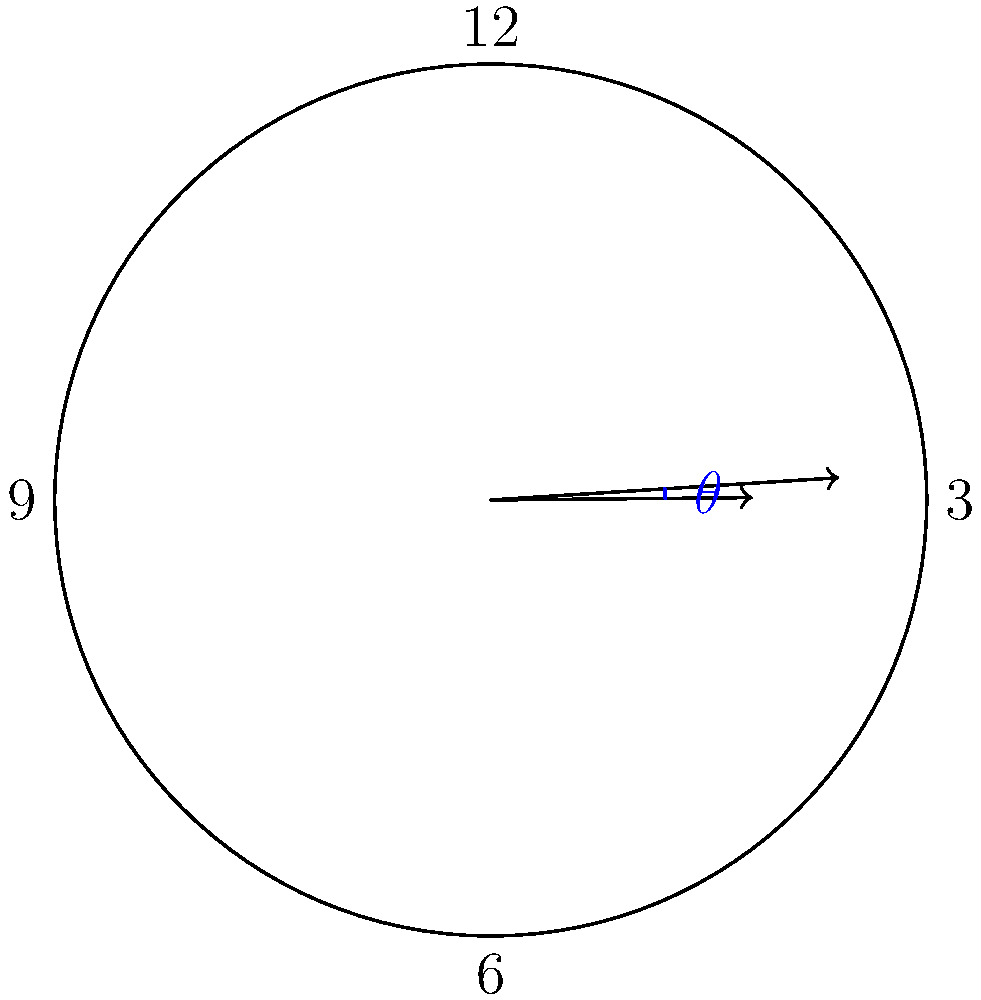Imagine you're playing with a magical clock that can show any time you want! If the hour hand points to 1 and the minute hand points to 7, what is the smallest angle $\theta$ (in degrees) between the two hands? Remember, the clock face is divided into 12 equal parts! Let's solve this step-by-step:

1) First, we need to understand how the clock hands move:
   - The hour hand makes a complete 360° rotation in 12 hours, so it moves at 360° ÷ 12 = 30° per hour.
   - The minute hand makes a complete 360° rotation in 1 hour, so it moves at 360° ÷ 60 = 6° per minute.

2) When the hour hand points to 1, it has moved 30° from the 12 o'clock position.

3) When the minute hand points to 7, it has moved 7 × 30° = 210° from the 12 o'clock position.

4) The angle between the hands is the absolute difference between these angles:
   $|\text{Minute hand angle} - \text{Hour hand angle}| = |210° - 30°| = 180°$

5) However, we need to find the smallest angle. If the angle is greater than 180°, we can subtract it from 360° to get the smaller angle on the other side of the circle.

6) In this case, 180° is exactly half of the circle, so it's already the smallest angle between the hands.

Therefore, the smallest angle between the hour hand and the minute hand is 180°.
Answer: 180° 